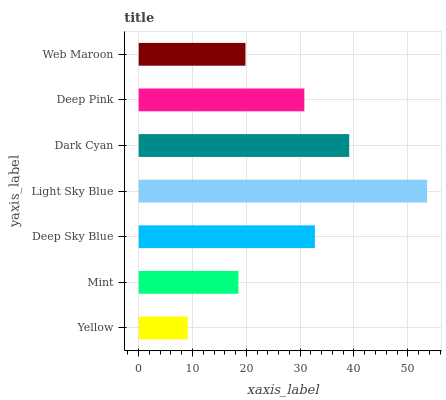Is Yellow the minimum?
Answer yes or no. Yes. Is Light Sky Blue the maximum?
Answer yes or no. Yes. Is Mint the minimum?
Answer yes or no. No. Is Mint the maximum?
Answer yes or no. No. Is Mint greater than Yellow?
Answer yes or no. Yes. Is Yellow less than Mint?
Answer yes or no. Yes. Is Yellow greater than Mint?
Answer yes or no. No. Is Mint less than Yellow?
Answer yes or no. No. Is Deep Pink the high median?
Answer yes or no. Yes. Is Deep Pink the low median?
Answer yes or no. Yes. Is Web Maroon the high median?
Answer yes or no. No. Is Web Maroon the low median?
Answer yes or no. No. 